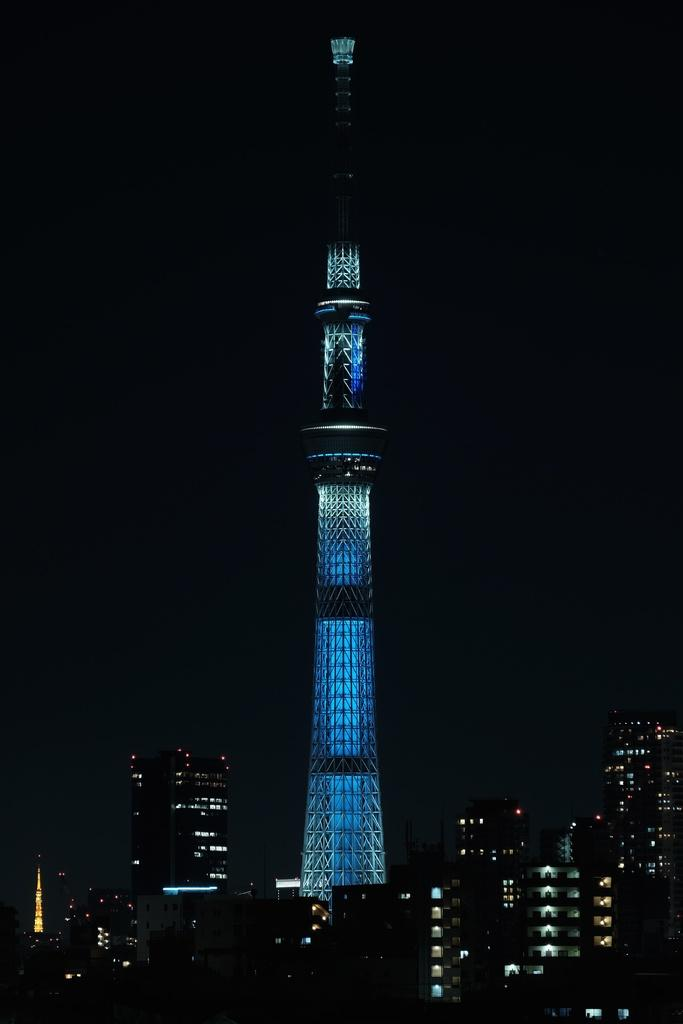What is the main structure in the image? There is a tower with lights in the image. What else can be seen at the bottom of the image? There is a group of buildings at the bottom of the image. How would you describe the overall appearance of the image? The background of the image is dark. What type of fang can be seen sticking out of the tower in the image? There is no fang present in the image; it features a tower with lights and a group of buildings. What kind of thing is being carried by the carriage in the image? There is no carriage present in the image. 